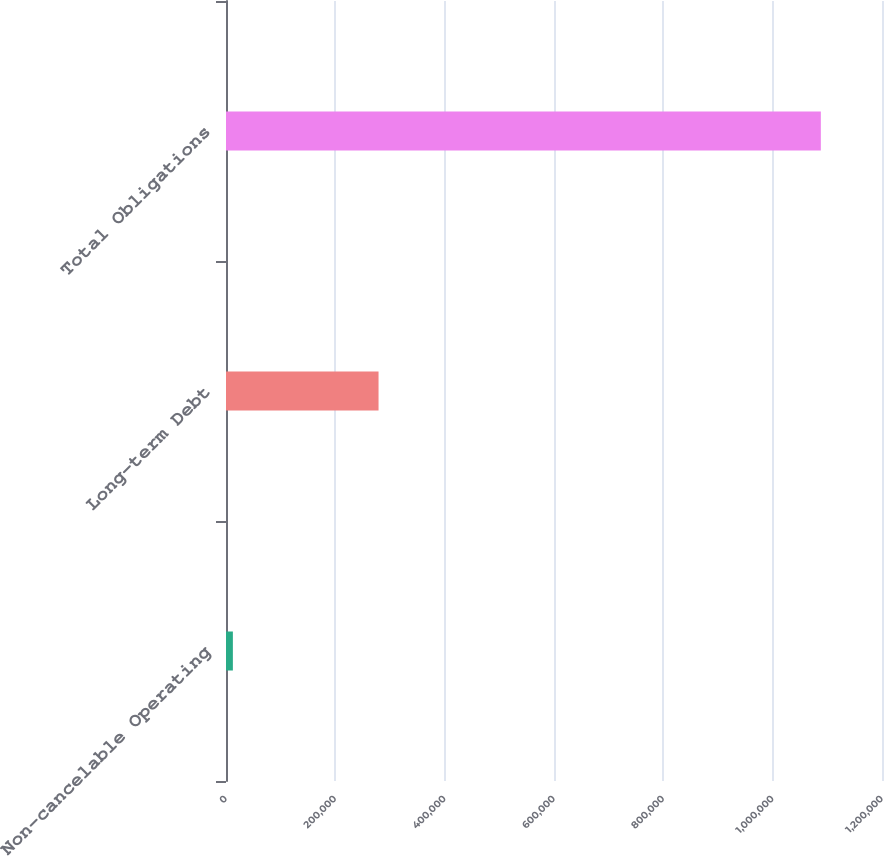<chart> <loc_0><loc_0><loc_500><loc_500><bar_chart><fcel>Non-cancelable Operating<fcel>Long-term Debt<fcel>Total Obligations<nl><fcel>12579<fcel>279043<fcel>1.08812e+06<nl></chart> 